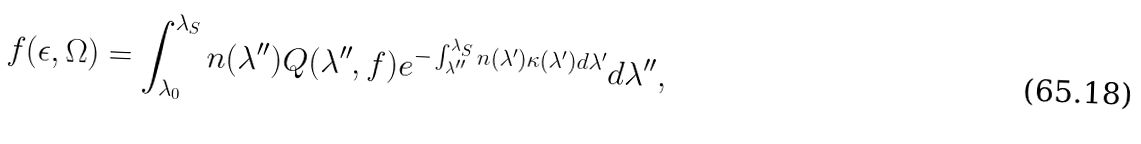<formula> <loc_0><loc_0><loc_500><loc_500>f ( \epsilon , \Omega ) = \int ^ { \lambda _ { S } } _ { \lambda _ { 0 } } n ( \lambda ^ { \prime \prime } ) Q ( \lambda ^ { \prime \prime } , f ) e ^ { - \int ^ { \lambda _ { S } } _ { \lambda ^ { \prime \prime } } n ( \lambda ^ { \prime } ) \kappa ( \lambda ^ { \prime } ) d \lambda ^ { \prime } } d \lambda ^ { \prime \prime } ,</formula> 